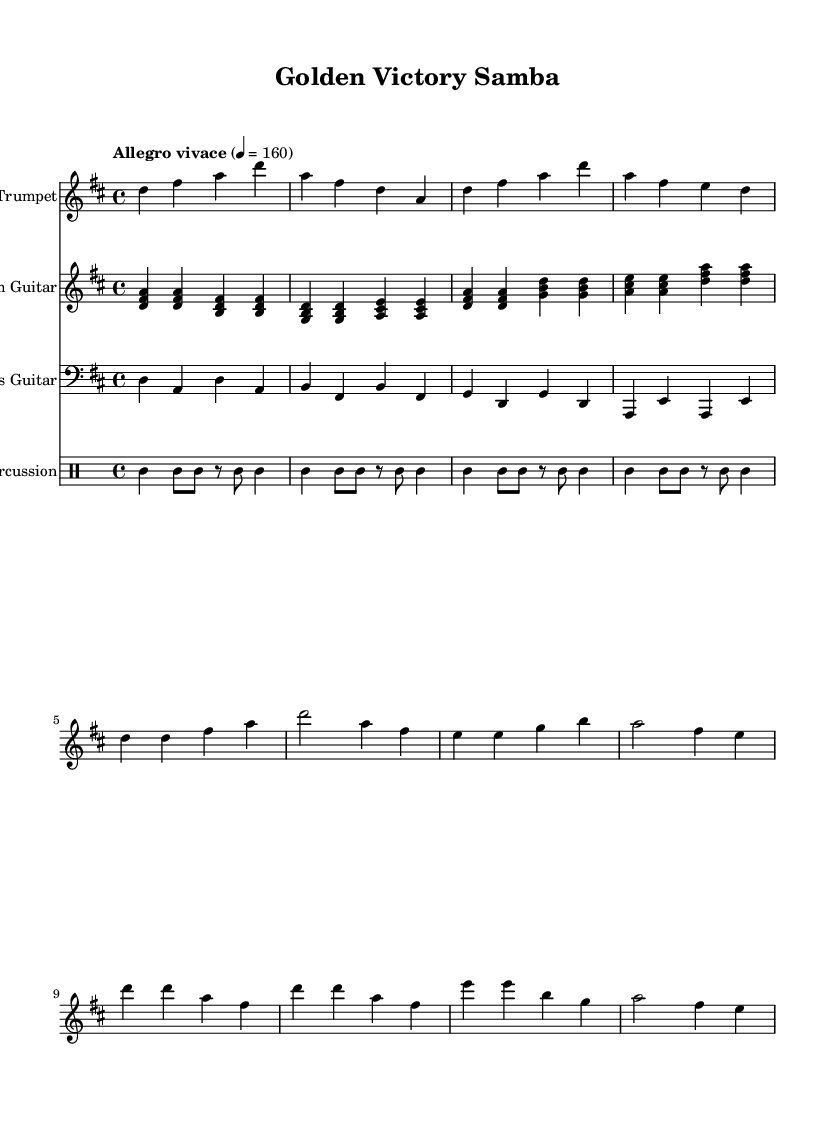What is the key signature of this music? The key signature is D major, which has two sharps (F# and C#). This can be determined by looking at the beginning of the music where the key signature is indicated.
Answer: D major What is the time signature of this music? The time signature is 4/4, which can be identified by the notation found at the beginning of the score. This indicates that there are four beats in each measure and the quarter note receives one beat.
Answer: 4/4 What is the tempo marking for this piece? The tempo is marked "Allegro vivace," which is typically an indication of a fast and lively pace, generally around 160 beats per minute. This is found in the tempo indication just below the time signature.
Answer: Allegro vivace How many instruments are featured in the score? There are four instruments featured: lead trumpet, rhythm guitar, bass guitar, and percussion. This is evident from the different staves listed in the score.
Answer: Four What is the rhythmic pattern used in the percussion section? The percussion section features a simplified clave rhythm, which consists of alternating strong and soft beats. This pattern is represented by the series of notes and rests in the percussion staff.
Answer: Clave rhythm Which section features the main melody? The main melody is in the trumpet section, which has melodic lines that stand out prominently against the harmonic support of the other instruments. The rhythm and note choices in the trumpet part indicate it carries the lead melody.
Answer: Trumpet What chords are primarily used in the verse? The primary chords in the verse are D, B, G, and A. These chords are indicated in the guitar part through the chord symbols and notes played, showing a traditional chord progression that supports the melody.
Answer: D, B, G, A 